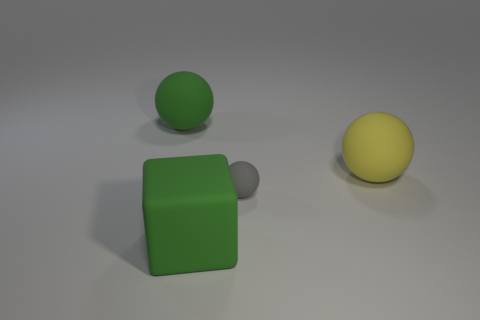There is another tiny matte object that is the same shape as the yellow rubber object; what color is it?
Ensure brevity in your answer.  Gray. How many objects are small gray matte objects or green matte blocks?
Offer a terse response. 2. There is a sphere that is the same color as the large rubber cube; what material is it?
Your answer should be very brief. Rubber. Are there any other large objects that have the same shape as the big yellow rubber thing?
Keep it short and to the point. Yes. There is a tiny gray thing; how many big matte spheres are on the right side of it?
Provide a short and direct response. 1. There is a large green thing right of the large matte sphere that is left of the yellow thing; what is its material?
Your answer should be very brief. Rubber. Are there any yellow balls that have the same size as the matte block?
Offer a terse response. Yes. What is the color of the matte sphere that is to the left of the gray sphere?
Give a very brief answer. Green. Are there any green cubes in front of the tiny gray matte object that is to the left of the big yellow ball?
Keep it short and to the point. Yes. How many other objects are the same color as the large cube?
Provide a succinct answer. 1. 